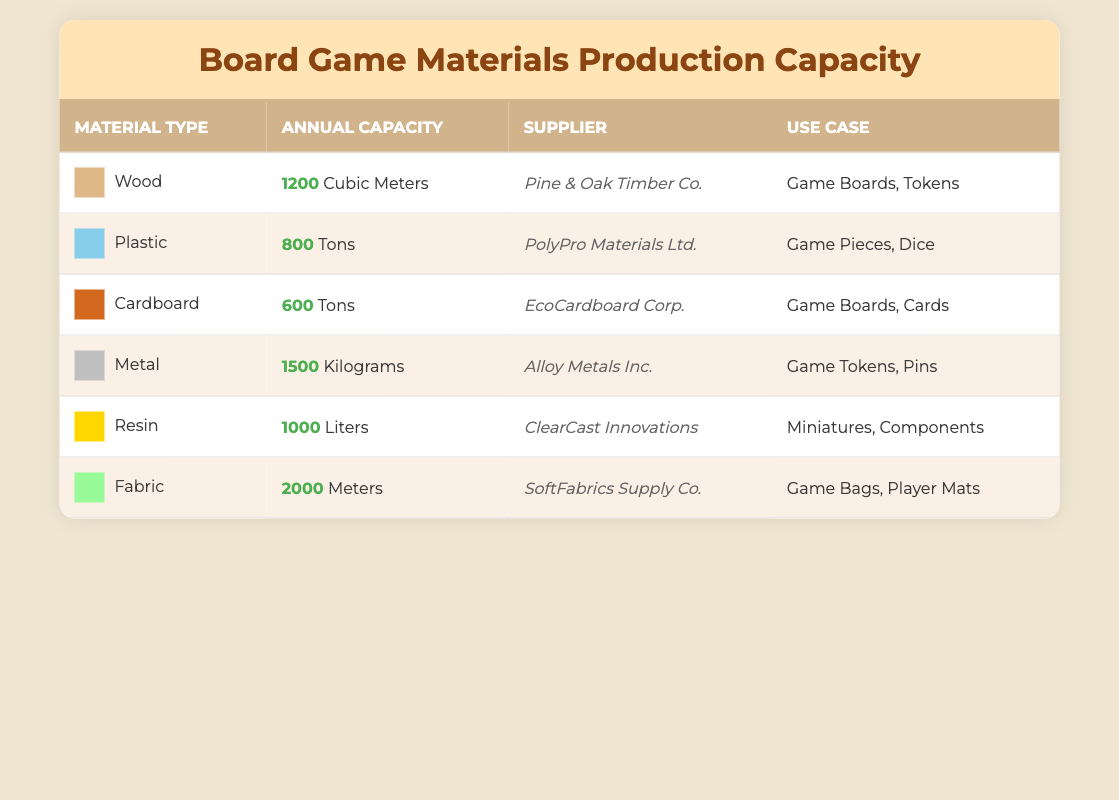What is the annual capacity of Wood? The table lists Wood's annual capacity as 1200 Cubic Meters.
Answer: 1200 Cubic Meters Which material has the highest annual capacity? By comparing the annual capacities listed in the table, Fabric has the highest at 2000 Meters.
Answer: Fabric How much annual capacity do Plastic and Resin have combined? The annual capacity for Plastic is 800 Tons and for Resin is 1000 Liters. Since they are in different units (Tons and Liters), they cannot be directly summed.
Answer: 1800 (but in different units) Is the annual capacity of Cardboard greater than that of Wood? The annual capacity of Cardboard is 600 Tons, while Wood's capacity is 1200 Cubic Meters. Since the units differ, a comparison cannot be made directly.
Answer: No What is the total annual capacity for all material types in the table? To obtain the total capacity, we sum up the values for each material's annual capacity: 1200 (Wood) + 800 (Plastic) + 600 (Cardboard) + 1500 (Metal) + 1000 (Resin) + 2000 (Fabric). This equals 6100, but again in different units (Cubic Meters, Tons, Kilograms, Liters, Meters). Therefore, it's specific to each unit.
Answer: 6100 (in different units) Is there a supplier for both Metal and Fabric? Upon checking the supplier column, Metal's supplier is Alloy Metals Inc., and Fabric's supplier is SoftFabrics Supply Co. Since these are different, the answer is no.
Answer: No What is the median annual capacity of the materials in the table? First, we list the annual capacities in similar units for comparison: Wood (1200 Cubic Meters), Plastic (800 Tons), Cardboard (600 Tons), Metal (1500 Kilograms), Resin (1000 Liters), Fabric (2000 Meters). Since we cannot convert easily, we see the sorted value order is 600 (Cardboard), 800 (Plastic), 1000 (Resin), 1200 (Wood), 1500 (Metal), 2000 (Fabric). The median of six values is the average of the 3rd and 4th: (1000 + 1200) / 2 = 1100 but it varies by unit.
Answer: 1100 (in different units) Which materials can be used for Game Boards? Referring to the Use Case column, Wood and Cardboard can both be used for Game Boards.
Answer: Wood, Cardboard What unit is used to measure the annual capacity of Fabric? In the table, Fabric's annual capacity is measured in Meters.
Answer: Meters 